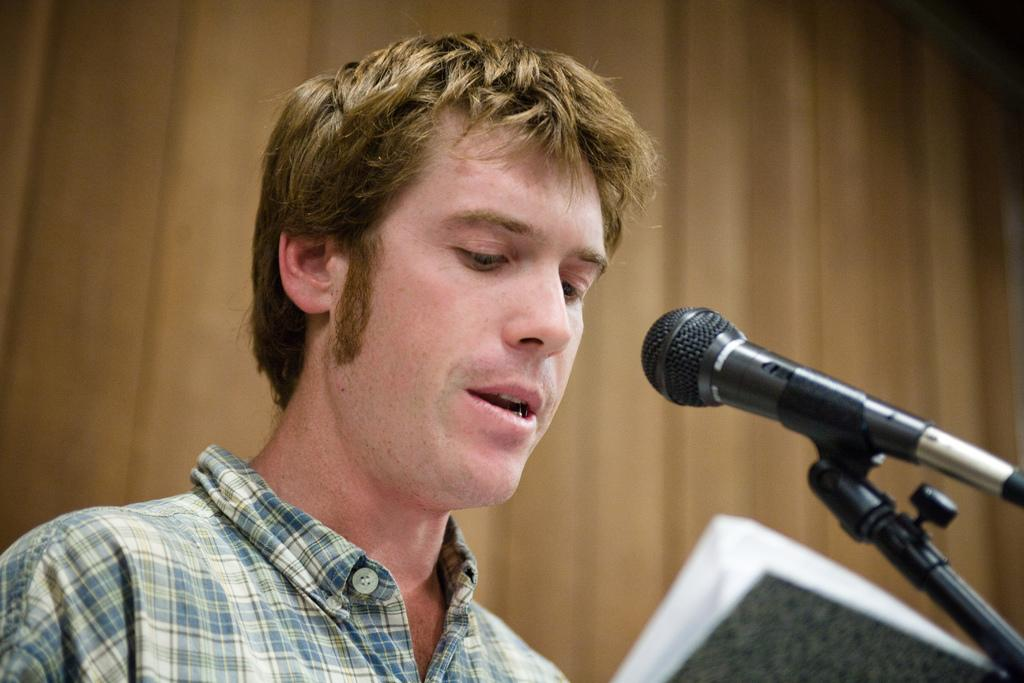Who is the main subject in the image? There is a man in the middle of the image. What object is in front of the man? There is a microphone (mic) in front of the man. Can you describe the background of the image? The background of the image is blurred. What type of gold jewelry is the beggar wearing in the image? There is no beggar or gold jewelry present in the image. Can you describe the cracker that the man is holding in the image? There is no cracker present in the image; the man is holding a microphone. 